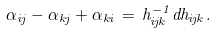Convert formula to latex. <formula><loc_0><loc_0><loc_500><loc_500>\alpha _ { i j } - \alpha _ { k j } + \alpha _ { k i } \, = \, h _ { i j k } ^ { - 1 } d h _ { i j k } .</formula> 